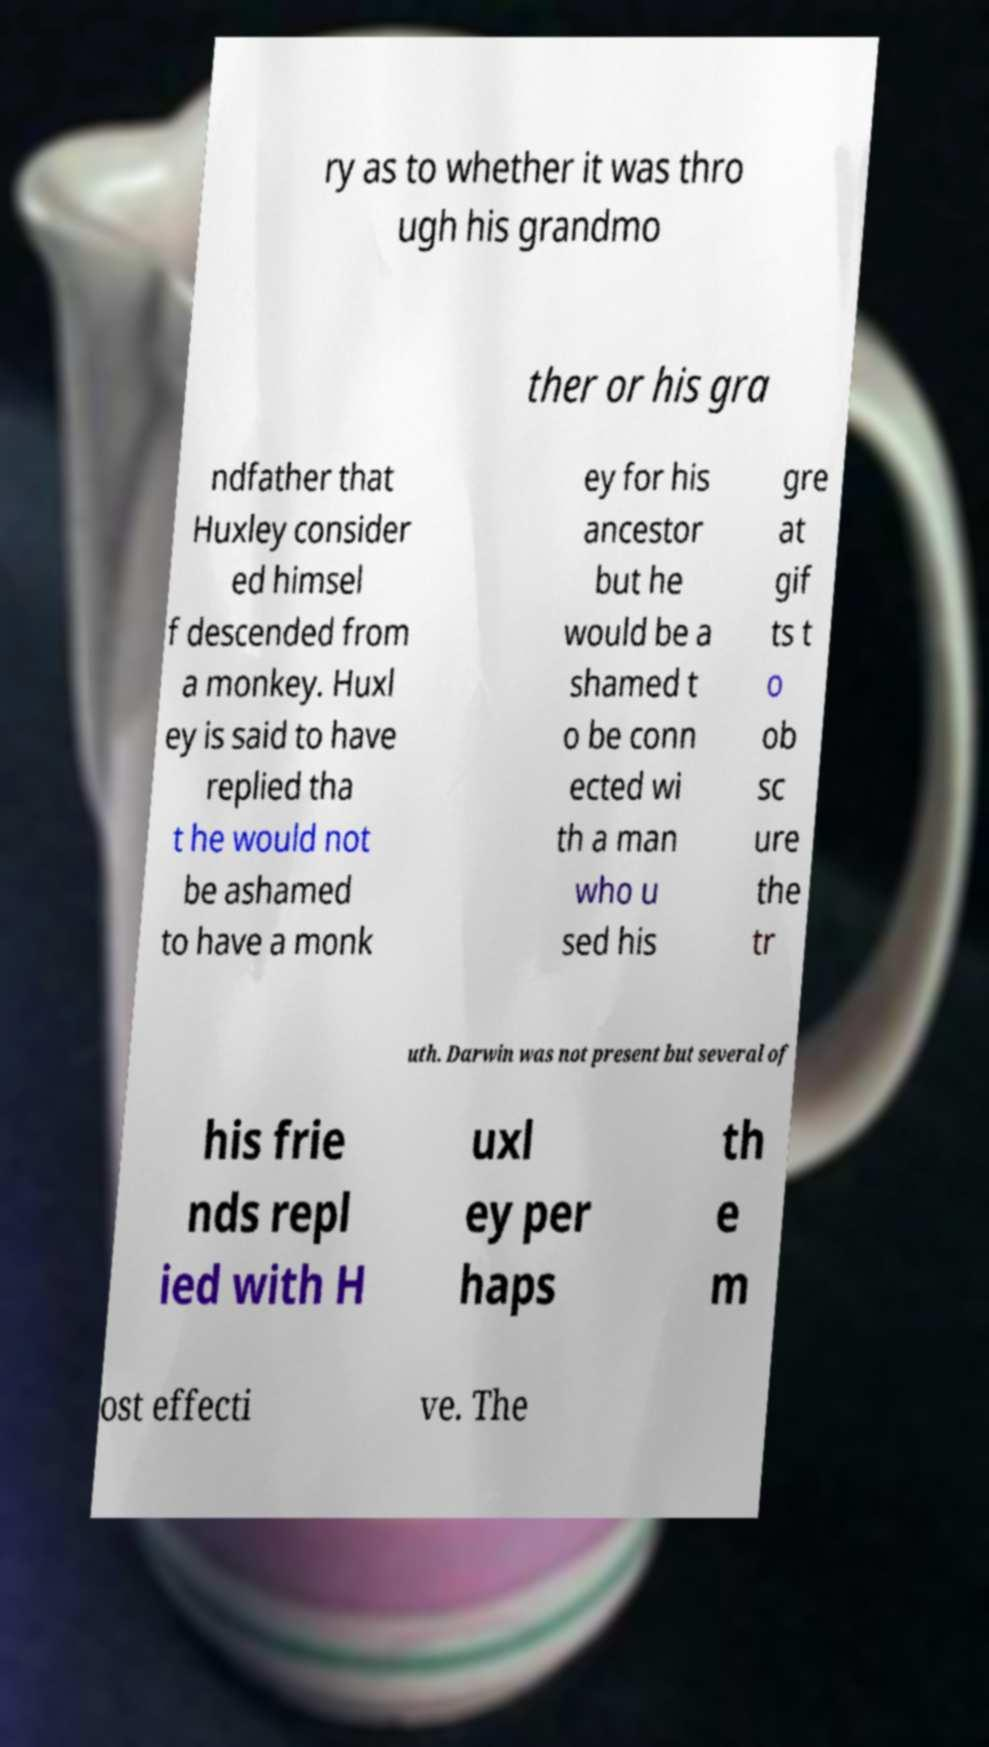Can you accurately transcribe the text from the provided image for me? ry as to whether it was thro ugh his grandmo ther or his gra ndfather that Huxley consider ed himsel f descended from a monkey. Huxl ey is said to have replied tha t he would not be ashamed to have a monk ey for his ancestor but he would be a shamed t o be conn ected wi th a man who u sed his gre at gif ts t o ob sc ure the tr uth. Darwin was not present but several of his frie nds repl ied with H uxl ey per haps th e m ost effecti ve. The 